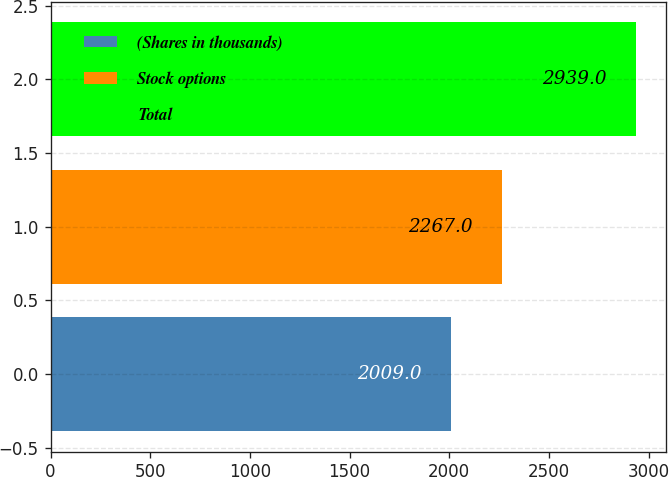Convert chart to OTSL. <chart><loc_0><loc_0><loc_500><loc_500><bar_chart><fcel>(Shares in thousands)<fcel>Stock options<fcel>Total<nl><fcel>2009<fcel>2267<fcel>2939<nl></chart> 